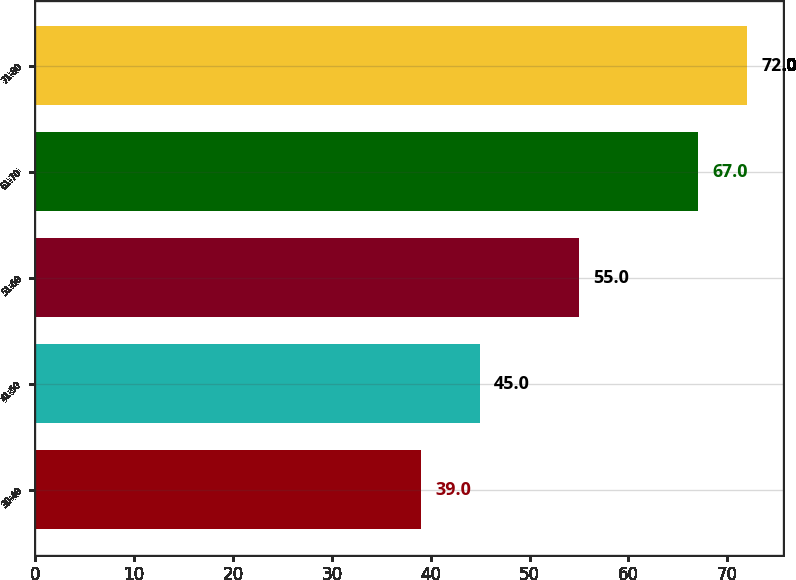Convert chart to OTSL. <chart><loc_0><loc_0><loc_500><loc_500><bar_chart><fcel>30-40<fcel>41-50<fcel>51-60<fcel>61-70<fcel>71-80<nl><fcel>39<fcel>45<fcel>55<fcel>67<fcel>72<nl></chart> 